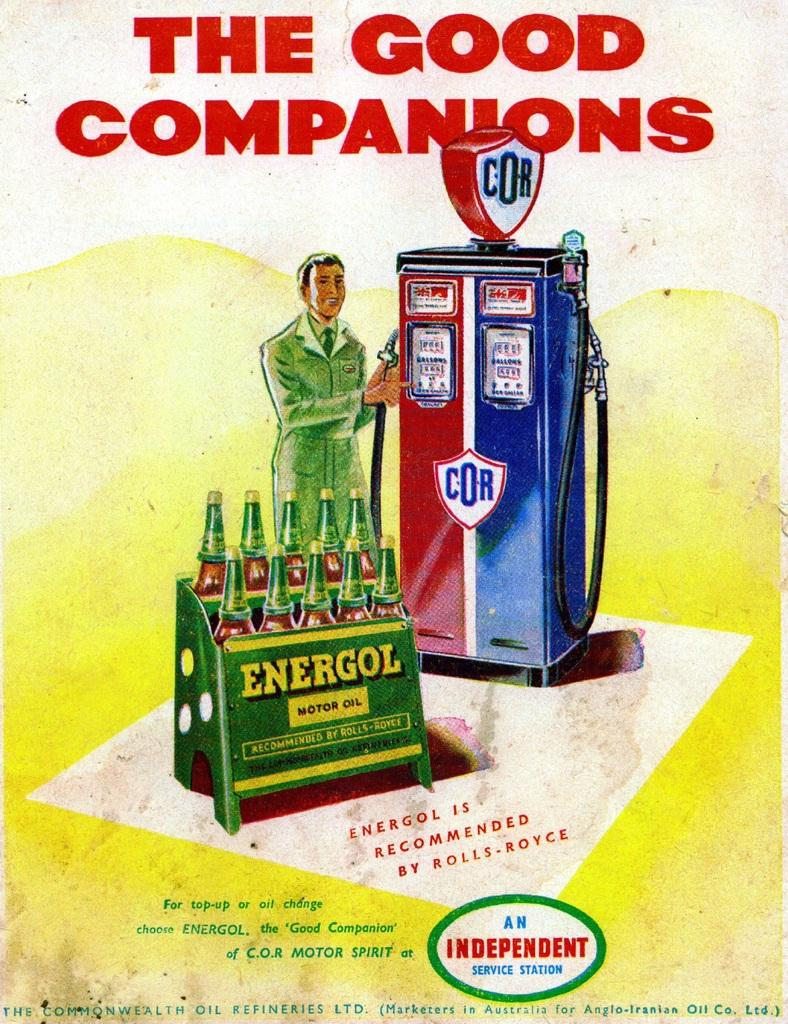<image>
Create a compact narrative representing the image presented. An old poster ad shows a cartoon of a man next to old style gas pumps and in front of a stand of Energol motor oil. 